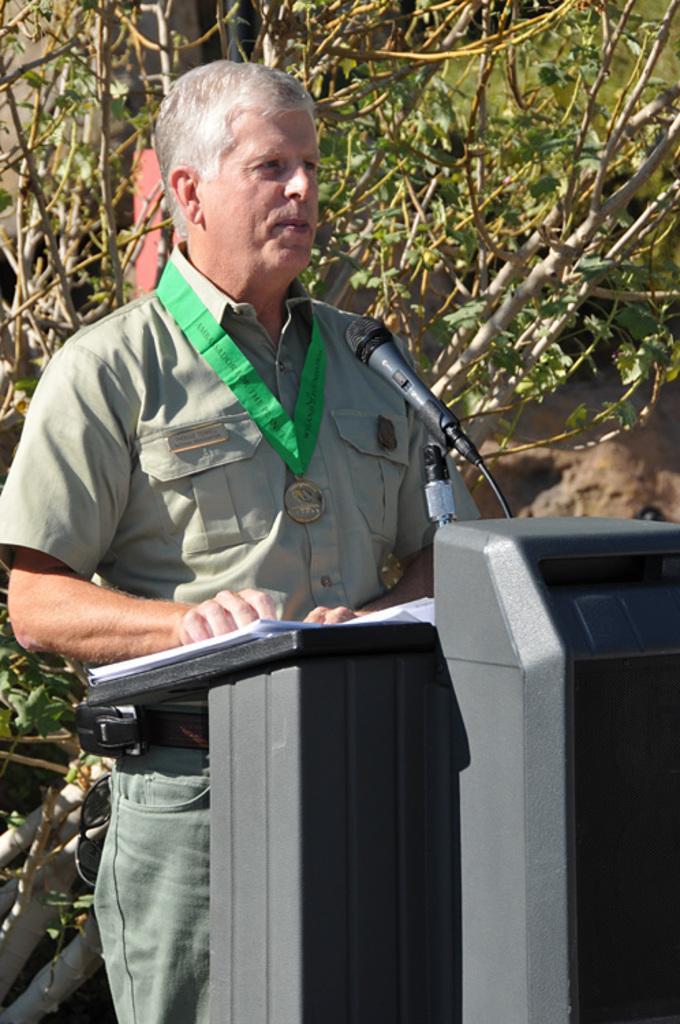In one or two sentences, can you explain what this image depicts? In the picture we can see a man standing near the desk and talking in the microphone which is to the desk and on the desk, we can see some papers, the man is wearing a uniform with a medal on the neck with a green color tag and behind the man we can see plants. 